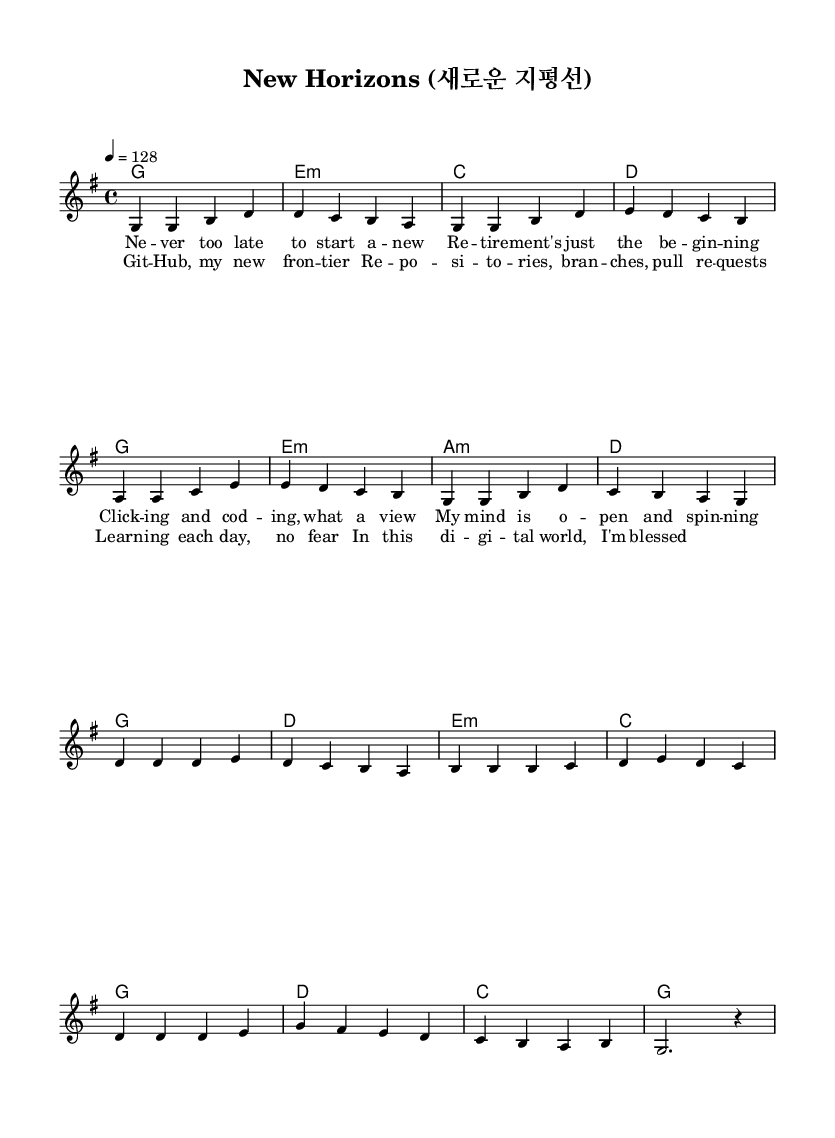What is the key signature of this music? The key signature is G major, which has one sharp (F#). This can be seen indicated at the beginning of the sheet music where the key signature is placed.
Answer: G major What is the time signature of this music? The time signature is 4/4, which denotes four beats in a measure and is indicated at the start of the score.
Answer: 4/4 What is the tempo marking of this music? The tempo marking indicates a speed of 128 beats per minute, specified with "4 = 128" in the header section.
Answer: 128 How many measures are in the melody section? By counting the distinct segments separated by bars in the melody line, there are 16 measures total, including both verses and choruses.
Answer: 16 What is the first chord in the piece? The first chord listed in the harmonic section is G major, as noted in the chord mode line where it starts the verse with "g1".
Answer: G What lyrical theme is presented in the chorus? The chorus expresses enthusiasm for learning and embracing new experiences in a digital age, aligning with the K-Pop theme of positivity and growth.
Answer: Learning and embracing new experiences What is the overall mood conveyed by the energetic rhythm and lyrics? The combination of an upbeat tempo and optimistic lyrics creates a lively and motivational atmosphere, typical of K-Pop tracks focused on growth and positivity.
Answer: Lively and motivational 